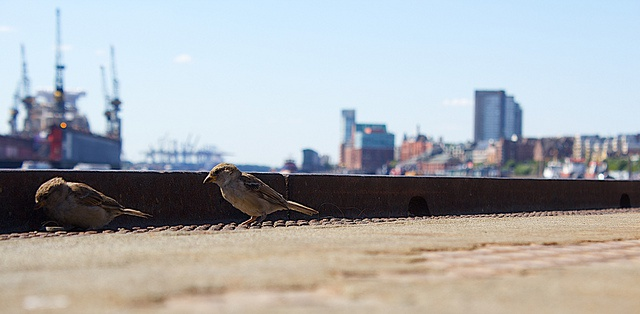Describe the objects in this image and their specific colors. I can see boat in lightblue, blue, and gray tones, bird in lightblue, black, maroon, and gray tones, bird in lightblue, black, maroon, and gray tones, and boat in lightblue, lightgray, darkgray, and gray tones in this image. 